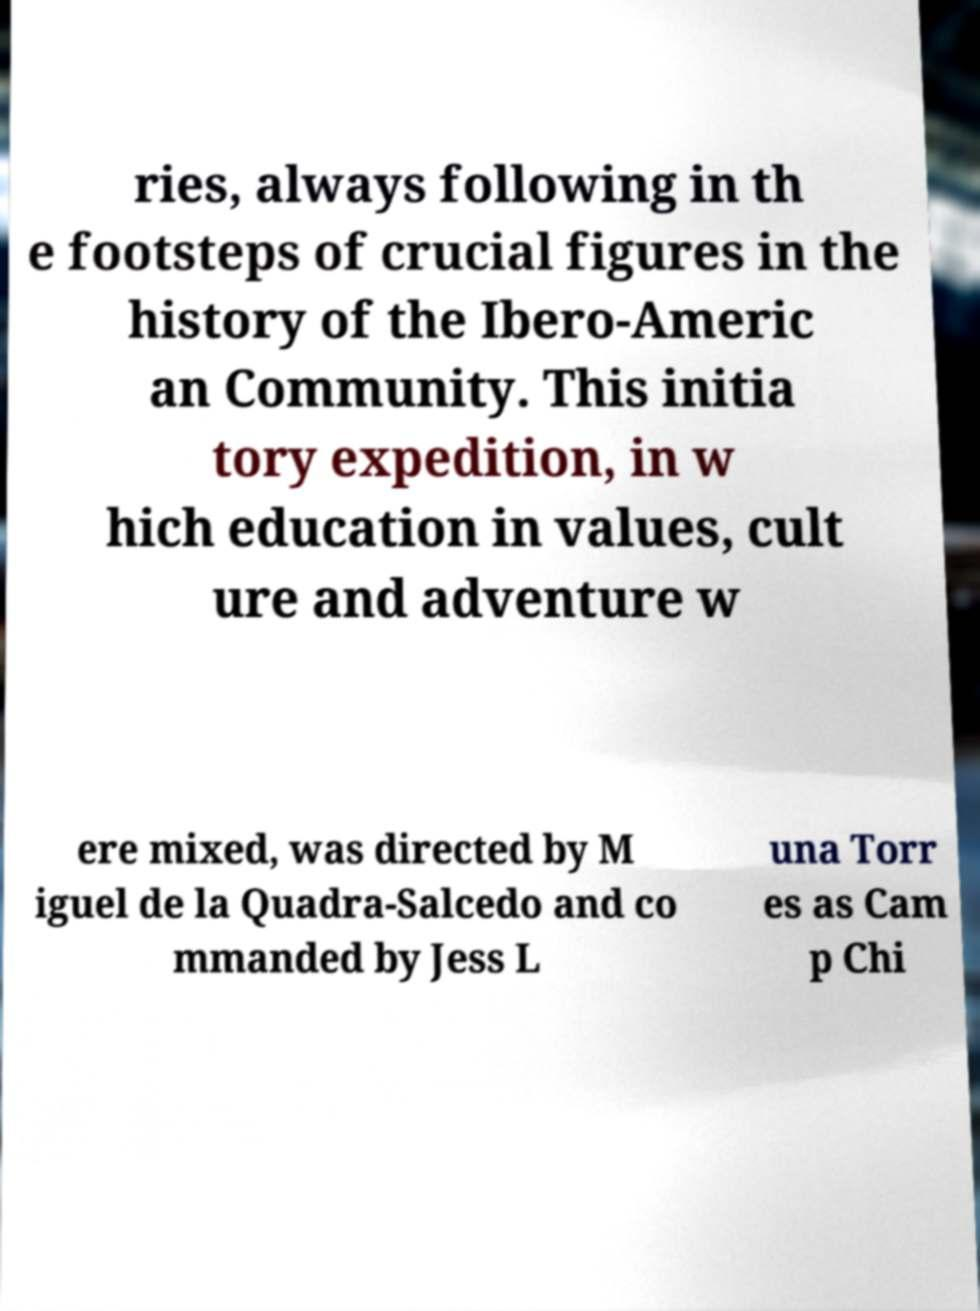I need the written content from this picture converted into text. Can you do that? ries, always following in th e footsteps of crucial figures in the history of the Ibero-Americ an Community. This initia tory expedition, in w hich education in values, cult ure and adventure w ere mixed, was directed by M iguel de la Quadra-Salcedo and co mmanded by Jess L una Torr es as Cam p Chi 